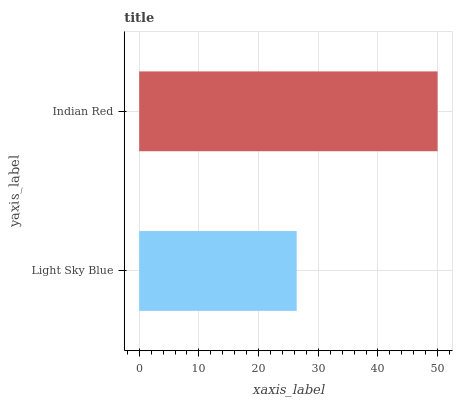Is Light Sky Blue the minimum?
Answer yes or no. Yes. Is Indian Red the maximum?
Answer yes or no. Yes. Is Indian Red the minimum?
Answer yes or no. No. Is Indian Red greater than Light Sky Blue?
Answer yes or no. Yes. Is Light Sky Blue less than Indian Red?
Answer yes or no. Yes. Is Light Sky Blue greater than Indian Red?
Answer yes or no. No. Is Indian Red less than Light Sky Blue?
Answer yes or no. No. Is Indian Red the high median?
Answer yes or no. Yes. Is Light Sky Blue the low median?
Answer yes or no. Yes. Is Light Sky Blue the high median?
Answer yes or no. No. Is Indian Red the low median?
Answer yes or no. No. 